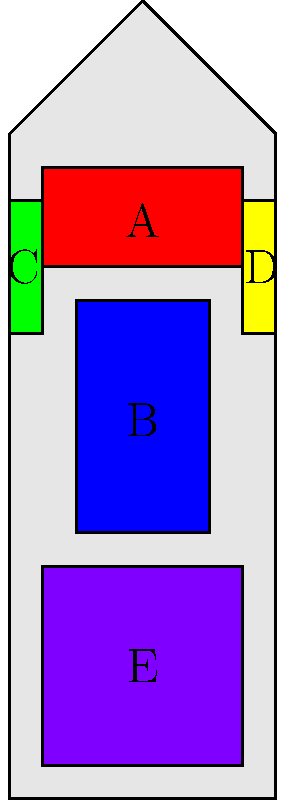As a fitness influencer who emphasizes proper muscle targeting in workouts, identify the muscle groups labeled A through E in the human anatomy illustration. Which label corresponds to the muscle group primarily targeted during a standard push-up exercise? To answer this question, let's break down the labeled muscle groups and their functions:

1. Label A (Red): This represents the chest muscles, also known as the pectoralis major.
2. Label B (Blue): This shows the abdominal muscles or rectus abdominis.
3. Label C (Green): This indicates the biceps brachii, located on the front of the upper arm.
4. Label D (Yellow): This represents the triceps brachii, located on the back of the upper arm.
5. Label E (Purple): This shows the quadriceps, the large muscles on the front of the thigh.

A standard push-up is a compound exercise that primarily targets the chest muscles (pectoralis major). While it also engages other muscle groups like the triceps and shoulders as synergists, and the core muscles for stabilization, the main focus is on the chest.

Therefore, the muscle group primarily targeted during a standard push-up exercise corresponds to label A, which represents the chest muscles (pectoralis major).
Answer: A 